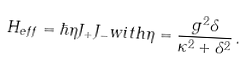Convert formula to latex. <formula><loc_0><loc_0><loc_500><loc_500>H _ { e f f } = \hbar { \eta } J _ { + } J _ { - } w i t h \eta = \frac { g ^ { 2 } \delta } { \kappa ^ { 2 } + \delta ^ { 2 } } \, .</formula> 